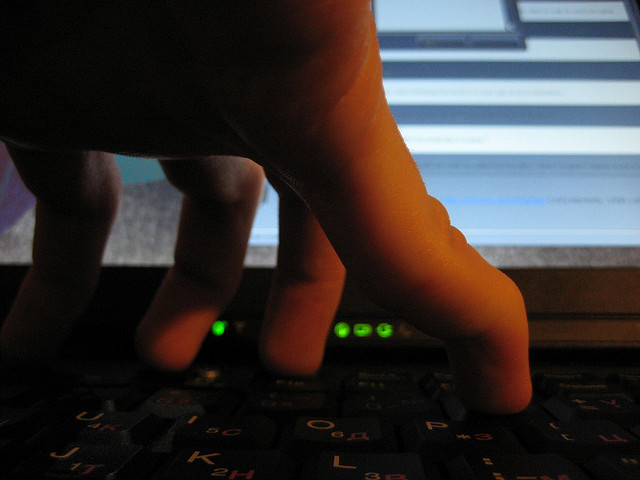Read all the text in this image. J U 1 P L K 